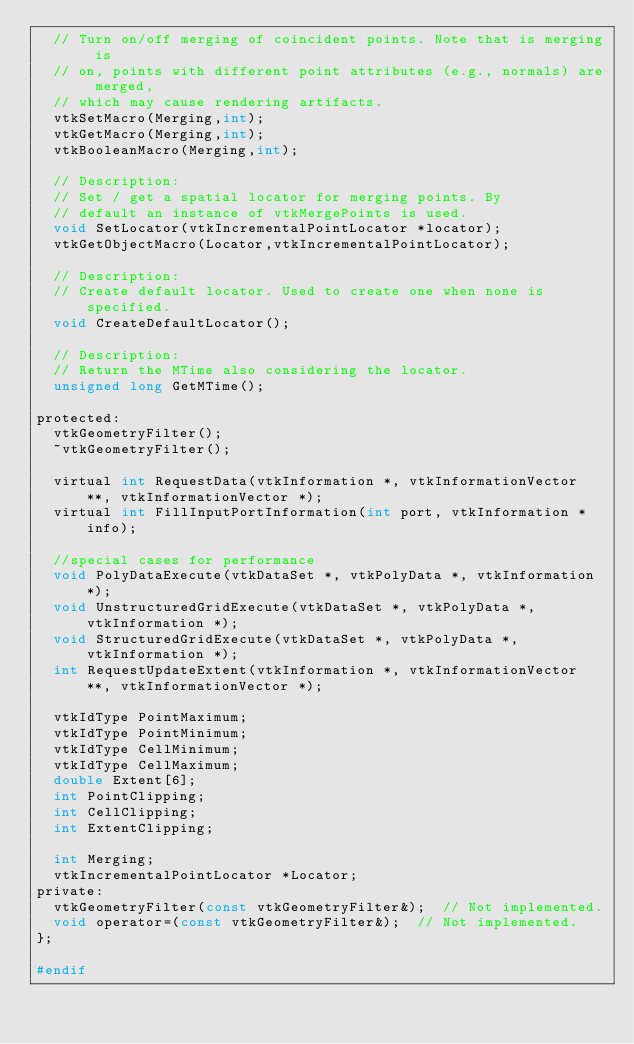<code> <loc_0><loc_0><loc_500><loc_500><_C_>  // Turn on/off merging of coincident points. Note that is merging is
  // on, points with different point attributes (e.g., normals) are merged,
  // which may cause rendering artifacts.
  vtkSetMacro(Merging,int);
  vtkGetMacro(Merging,int);
  vtkBooleanMacro(Merging,int);

  // Description:
  // Set / get a spatial locator for merging points. By
  // default an instance of vtkMergePoints is used.
  void SetLocator(vtkIncrementalPointLocator *locator);
  vtkGetObjectMacro(Locator,vtkIncrementalPointLocator);

  // Description:
  // Create default locator. Used to create one when none is specified.
  void CreateDefaultLocator();

  // Description:
  // Return the MTime also considering the locator.
  unsigned long GetMTime();

protected:
  vtkGeometryFilter();
  ~vtkGeometryFilter();

  virtual int RequestData(vtkInformation *, vtkInformationVector **, vtkInformationVector *);
  virtual int FillInputPortInformation(int port, vtkInformation *info);

  //special cases for performance
  void PolyDataExecute(vtkDataSet *, vtkPolyData *, vtkInformation *);
  void UnstructuredGridExecute(vtkDataSet *, vtkPolyData *, vtkInformation *);
  void StructuredGridExecute(vtkDataSet *, vtkPolyData *, vtkInformation *);
  int RequestUpdateExtent(vtkInformation *, vtkInformationVector **, vtkInformationVector *);

  vtkIdType PointMaximum;
  vtkIdType PointMinimum;
  vtkIdType CellMinimum;
  vtkIdType CellMaximum;
  double Extent[6];
  int PointClipping;
  int CellClipping;
  int ExtentClipping;

  int Merging;
  vtkIncrementalPointLocator *Locator;
private:
  vtkGeometryFilter(const vtkGeometryFilter&);  // Not implemented.
  void operator=(const vtkGeometryFilter&);  // Not implemented.
};

#endif


</code> 